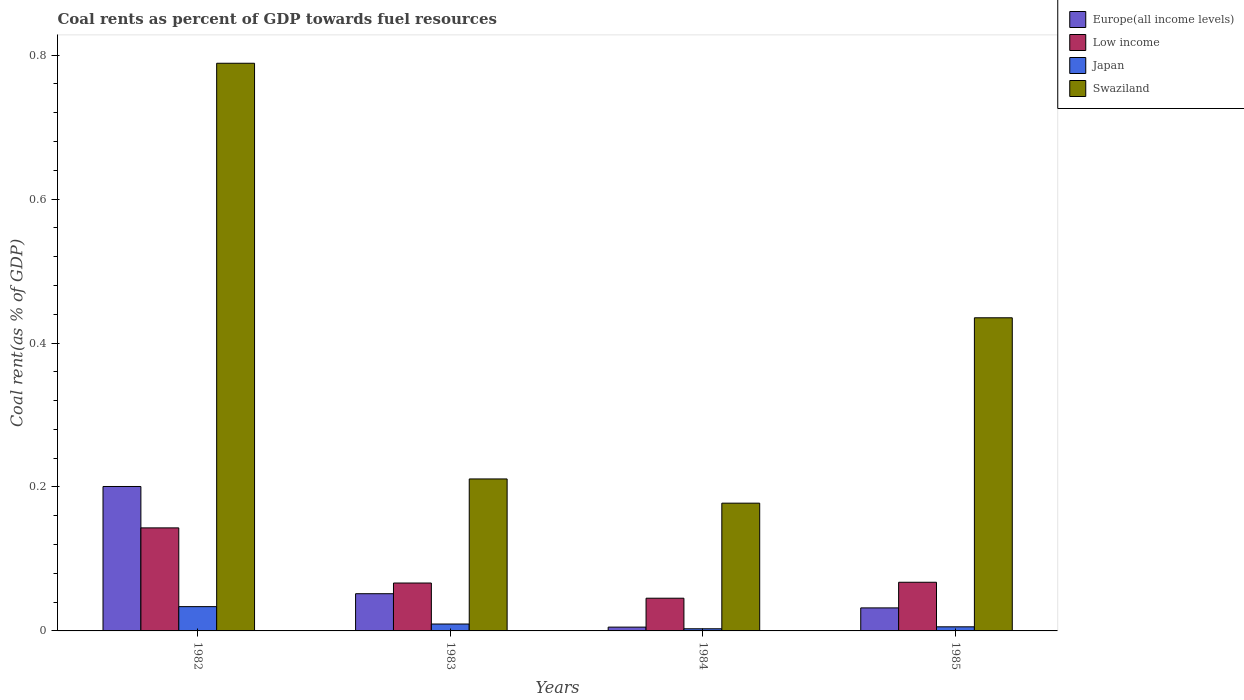How many different coloured bars are there?
Ensure brevity in your answer.  4. How many groups of bars are there?
Provide a short and direct response. 4. Are the number of bars per tick equal to the number of legend labels?
Your response must be concise. Yes. Are the number of bars on each tick of the X-axis equal?
Offer a terse response. Yes. What is the coal rent in Japan in 1985?
Your response must be concise. 0.01. Across all years, what is the maximum coal rent in Japan?
Make the answer very short. 0.03. Across all years, what is the minimum coal rent in Europe(all income levels)?
Ensure brevity in your answer.  0.01. In which year was the coal rent in Low income minimum?
Provide a short and direct response. 1984. What is the total coal rent in Europe(all income levels) in the graph?
Offer a terse response. 0.29. What is the difference between the coal rent in Japan in 1984 and that in 1985?
Provide a short and direct response. -0. What is the difference between the coal rent in Europe(all income levels) in 1982 and the coal rent in Swaziland in 1983?
Provide a short and direct response. -0.01. What is the average coal rent in Swaziland per year?
Offer a very short reply. 0.4. In the year 1982, what is the difference between the coal rent in Low income and coal rent in Swaziland?
Provide a succinct answer. -0.65. What is the ratio of the coal rent in Europe(all income levels) in 1982 to that in 1983?
Offer a terse response. 3.88. Is the coal rent in Low income in 1982 less than that in 1984?
Your answer should be very brief. No. What is the difference between the highest and the second highest coal rent in Swaziland?
Provide a short and direct response. 0.35. What is the difference between the highest and the lowest coal rent in Swaziland?
Provide a short and direct response. 0.61. What does the 1st bar from the left in 1985 represents?
Offer a terse response. Europe(all income levels). What does the 3rd bar from the right in 1984 represents?
Offer a very short reply. Low income. Is it the case that in every year, the sum of the coal rent in Japan and coal rent in Low income is greater than the coal rent in Europe(all income levels)?
Your response must be concise. No. What is the difference between two consecutive major ticks on the Y-axis?
Offer a terse response. 0.2. Does the graph contain any zero values?
Provide a short and direct response. No. Does the graph contain grids?
Give a very brief answer. No. Where does the legend appear in the graph?
Offer a terse response. Top right. How many legend labels are there?
Provide a succinct answer. 4. How are the legend labels stacked?
Make the answer very short. Vertical. What is the title of the graph?
Your answer should be compact. Coal rents as percent of GDP towards fuel resources. What is the label or title of the Y-axis?
Keep it short and to the point. Coal rent(as % of GDP). What is the Coal rent(as % of GDP) in Europe(all income levels) in 1982?
Your answer should be compact. 0.2. What is the Coal rent(as % of GDP) of Low income in 1982?
Provide a succinct answer. 0.14. What is the Coal rent(as % of GDP) in Japan in 1982?
Your answer should be compact. 0.03. What is the Coal rent(as % of GDP) of Swaziland in 1982?
Your answer should be very brief. 0.79. What is the Coal rent(as % of GDP) in Europe(all income levels) in 1983?
Provide a succinct answer. 0.05. What is the Coal rent(as % of GDP) in Low income in 1983?
Provide a short and direct response. 0.07. What is the Coal rent(as % of GDP) of Japan in 1983?
Offer a very short reply. 0.01. What is the Coal rent(as % of GDP) of Swaziland in 1983?
Give a very brief answer. 0.21. What is the Coal rent(as % of GDP) of Europe(all income levels) in 1984?
Offer a very short reply. 0.01. What is the Coal rent(as % of GDP) of Low income in 1984?
Provide a succinct answer. 0.05. What is the Coal rent(as % of GDP) of Japan in 1984?
Your answer should be compact. 0. What is the Coal rent(as % of GDP) of Swaziland in 1984?
Ensure brevity in your answer.  0.18. What is the Coal rent(as % of GDP) in Europe(all income levels) in 1985?
Give a very brief answer. 0.03. What is the Coal rent(as % of GDP) of Low income in 1985?
Provide a succinct answer. 0.07. What is the Coal rent(as % of GDP) in Japan in 1985?
Your answer should be very brief. 0.01. What is the Coal rent(as % of GDP) in Swaziland in 1985?
Ensure brevity in your answer.  0.44. Across all years, what is the maximum Coal rent(as % of GDP) of Europe(all income levels)?
Provide a succinct answer. 0.2. Across all years, what is the maximum Coal rent(as % of GDP) of Low income?
Your answer should be very brief. 0.14. Across all years, what is the maximum Coal rent(as % of GDP) in Japan?
Offer a very short reply. 0.03. Across all years, what is the maximum Coal rent(as % of GDP) of Swaziland?
Your response must be concise. 0.79. Across all years, what is the minimum Coal rent(as % of GDP) in Europe(all income levels)?
Provide a succinct answer. 0.01. Across all years, what is the minimum Coal rent(as % of GDP) in Low income?
Ensure brevity in your answer.  0.05. Across all years, what is the minimum Coal rent(as % of GDP) of Japan?
Your answer should be very brief. 0. Across all years, what is the minimum Coal rent(as % of GDP) of Swaziland?
Provide a succinct answer. 0.18. What is the total Coal rent(as % of GDP) in Europe(all income levels) in the graph?
Your answer should be compact. 0.29. What is the total Coal rent(as % of GDP) of Low income in the graph?
Offer a very short reply. 0.32. What is the total Coal rent(as % of GDP) of Japan in the graph?
Offer a very short reply. 0.05. What is the total Coal rent(as % of GDP) in Swaziland in the graph?
Your response must be concise. 1.61. What is the difference between the Coal rent(as % of GDP) in Europe(all income levels) in 1982 and that in 1983?
Your answer should be compact. 0.15. What is the difference between the Coal rent(as % of GDP) of Low income in 1982 and that in 1983?
Offer a terse response. 0.08. What is the difference between the Coal rent(as % of GDP) of Japan in 1982 and that in 1983?
Make the answer very short. 0.02. What is the difference between the Coal rent(as % of GDP) in Swaziland in 1982 and that in 1983?
Offer a terse response. 0.58. What is the difference between the Coal rent(as % of GDP) of Europe(all income levels) in 1982 and that in 1984?
Your answer should be very brief. 0.2. What is the difference between the Coal rent(as % of GDP) of Low income in 1982 and that in 1984?
Provide a succinct answer. 0.1. What is the difference between the Coal rent(as % of GDP) in Japan in 1982 and that in 1984?
Your answer should be very brief. 0.03. What is the difference between the Coal rent(as % of GDP) of Swaziland in 1982 and that in 1984?
Provide a short and direct response. 0.61. What is the difference between the Coal rent(as % of GDP) of Europe(all income levels) in 1982 and that in 1985?
Your answer should be very brief. 0.17. What is the difference between the Coal rent(as % of GDP) of Low income in 1982 and that in 1985?
Keep it short and to the point. 0.08. What is the difference between the Coal rent(as % of GDP) in Japan in 1982 and that in 1985?
Your answer should be compact. 0.03. What is the difference between the Coal rent(as % of GDP) of Swaziland in 1982 and that in 1985?
Ensure brevity in your answer.  0.35. What is the difference between the Coal rent(as % of GDP) in Europe(all income levels) in 1983 and that in 1984?
Provide a succinct answer. 0.05. What is the difference between the Coal rent(as % of GDP) of Low income in 1983 and that in 1984?
Provide a succinct answer. 0.02. What is the difference between the Coal rent(as % of GDP) of Japan in 1983 and that in 1984?
Give a very brief answer. 0.01. What is the difference between the Coal rent(as % of GDP) of Swaziland in 1983 and that in 1984?
Offer a very short reply. 0.03. What is the difference between the Coal rent(as % of GDP) of Europe(all income levels) in 1983 and that in 1985?
Offer a very short reply. 0.02. What is the difference between the Coal rent(as % of GDP) of Low income in 1983 and that in 1985?
Provide a short and direct response. -0. What is the difference between the Coal rent(as % of GDP) of Japan in 1983 and that in 1985?
Give a very brief answer. 0. What is the difference between the Coal rent(as % of GDP) of Swaziland in 1983 and that in 1985?
Your answer should be very brief. -0.22. What is the difference between the Coal rent(as % of GDP) of Europe(all income levels) in 1984 and that in 1985?
Offer a very short reply. -0.03. What is the difference between the Coal rent(as % of GDP) in Low income in 1984 and that in 1985?
Provide a succinct answer. -0.02. What is the difference between the Coal rent(as % of GDP) in Japan in 1984 and that in 1985?
Your response must be concise. -0. What is the difference between the Coal rent(as % of GDP) in Swaziland in 1984 and that in 1985?
Give a very brief answer. -0.26. What is the difference between the Coal rent(as % of GDP) in Europe(all income levels) in 1982 and the Coal rent(as % of GDP) in Low income in 1983?
Offer a terse response. 0.13. What is the difference between the Coal rent(as % of GDP) of Europe(all income levels) in 1982 and the Coal rent(as % of GDP) of Japan in 1983?
Ensure brevity in your answer.  0.19. What is the difference between the Coal rent(as % of GDP) in Europe(all income levels) in 1982 and the Coal rent(as % of GDP) in Swaziland in 1983?
Offer a very short reply. -0.01. What is the difference between the Coal rent(as % of GDP) of Low income in 1982 and the Coal rent(as % of GDP) of Japan in 1983?
Provide a short and direct response. 0.13. What is the difference between the Coal rent(as % of GDP) of Low income in 1982 and the Coal rent(as % of GDP) of Swaziland in 1983?
Provide a short and direct response. -0.07. What is the difference between the Coal rent(as % of GDP) in Japan in 1982 and the Coal rent(as % of GDP) in Swaziland in 1983?
Keep it short and to the point. -0.18. What is the difference between the Coal rent(as % of GDP) of Europe(all income levels) in 1982 and the Coal rent(as % of GDP) of Low income in 1984?
Ensure brevity in your answer.  0.16. What is the difference between the Coal rent(as % of GDP) of Europe(all income levels) in 1982 and the Coal rent(as % of GDP) of Japan in 1984?
Offer a very short reply. 0.2. What is the difference between the Coal rent(as % of GDP) in Europe(all income levels) in 1982 and the Coal rent(as % of GDP) in Swaziland in 1984?
Ensure brevity in your answer.  0.02. What is the difference between the Coal rent(as % of GDP) of Low income in 1982 and the Coal rent(as % of GDP) of Japan in 1984?
Your response must be concise. 0.14. What is the difference between the Coal rent(as % of GDP) in Low income in 1982 and the Coal rent(as % of GDP) in Swaziland in 1984?
Your answer should be compact. -0.03. What is the difference between the Coal rent(as % of GDP) of Japan in 1982 and the Coal rent(as % of GDP) of Swaziland in 1984?
Ensure brevity in your answer.  -0.14. What is the difference between the Coal rent(as % of GDP) of Europe(all income levels) in 1982 and the Coal rent(as % of GDP) of Low income in 1985?
Keep it short and to the point. 0.13. What is the difference between the Coal rent(as % of GDP) of Europe(all income levels) in 1982 and the Coal rent(as % of GDP) of Japan in 1985?
Provide a short and direct response. 0.2. What is the difference between the Coal rent(as % of GDP) in Europe(all income levels) in 1982 and the Coal rent(as % of GDP) in Swaziland in 1985?
Your answer should be compact. -0.23. What is the difference between the Coal rent(as % of GDP) in Low income in 1982 and the Coal rent(as % of GDP) in Japan in 1985?
Your response must be concise. 0.14. What is the difference between the Coal rent(as % of GDP) of Low income in 1982 and the Coal rent(as % of GDP) of Swaziland in 1985?
Offer a very short reply. -0.29. What is the difference between the Coal rent(as % of GDP) of Japan in 1982 and the Coal rent(as % of GDP) of Swaziland in 1985?
Make the answer very short. -0.4. What is the difference between the Coal rent(as % of GDP) of Europe(all income levels) in 1983 and the Coal rent(as % of GDP) of Low income in 1984?
Offer a very short reply. 0.01. What is the difference between the Coal rent(as % of GDP) in Europe(all income levels) in 1983 and the Coal rent(as % of GDP) in Japan in 1984?
Your answer should be compact. 0.05. What is the difference between the Coal rent(as % of GDP) of Europe(all income levels) in 1983 and the Coal rent(as % of GDP) of Swaziland in 1984?
Offer a very short reply. -0.13. What is the difference between the Coal rent(as % of GDP) in Low income in 1983 and the Coal rent(as % of GDP) in Japan in 1984?
Your answer should be compact. 0.06. What is the difference between the Coal rent(as % of GDP) in Low income in 1983 and the Coal rent(as % of GDP) in Swaziland in 1984?
Your answer should be very brief. -0.11. What is the difference between the Coal rent(as % of GDP) in Japan in 1983 and the Coal rent(as % of GDP) in Swaziland in 1984?
Your answer should be compact. -0.17. What is the difference between the Coal rent(as % of GDP) in Europe(all income levels) in 1983 and the Coal rent(as % of GDP) in Low income in 1985?
Provide a short and direct response. -0.02. What is the difference between the Coal rent(as % of GDP) in Europe(all income levels) in 1983 and the Coal rent(as % of GDP) in Japan in 1985?
Provide a short and direct response. 0.05. What is the difference between the Coal rent(as % of GDP) of Europe(all income levels) in 1983 and the Coal rent(as % of GDP) of Swaziland in 1985?
Your answer should be compact. -0.38. What is the difference between the Coal rent(as % of GDP) in Low income in 1983 and the Coal rent(as % of GDP) in Japan in 1985?
Provide a short and direct response. 0.06. What is the difference between the Coal rent(as % of GDP) in Low income in 1983 and the Coal rent(as % of GDP) in Swaziland in 1985?
Provide a short and direct response. -0.37. What is the difference between the Coal rent(as % of GDP) in Japan in 1983 and the Coal rent(as % of GDP) in Swaziland in 1985?
Offer a very short reply. -0.43. What is the difference between the Coal rent(as % of GDP) in Europe(all income levels) in 1984 and the Coal rent(as % of GDP) in Low income in 1985?
Offer a very short reply. -0.06. What is the difference between the Coal rent(as % of GDP) in Europe(all income levels) in 1984 and the Coal rent(as % of GDP) in Japan in 1985?
Provide a short and direct response. -0. What is the difference between the Coal rent(as % of GDP) in Europe(all income levels) in 1984 and the Coal rent(as % of GDP) in Swaziland in 1985?
Provide a succinct answer. -0.43. What is the difference between the Coal rent(as % of GDP) of Low income in 1984 and the Coal rent(as % of GDP) of Japan in 1985?
Your response must be concise. 0.04. What is the difference between the Coal rent(as % of GDP) in Low income in 1984 and the Coal rent(as % of GDP) in Swaziland in 1985?
Your response must be concise. -0.39. What is the difference between the Coal rent(as % of GDP) in Japan in 1984 and the Coal rent(as % of GDP) in Swaziland in 1985?
Give a very brief answer. -0.43. What is the average Coal rent(as % of GDP) of Europe(all income levels) per year?
Offer a very short reply. 0.07. What is the average Coal rent(as % of GDP) of Low income per year?
Ensure brevity in your answer.  0.08. What is the average Coal rent(as % of GDP) in Japan per year?
Offer a terse response. 0.01. What is the average Coal rent(as % of GDP) of Swaziland per year?
Provide a succinct answer. 0.4. In the year 1982, what is the difference between the Coal rent(as % of GDP) of Europe(all income levels) and Coal rent(as % of GDP) of Low income?
Your answer should be compact. 0.06. In the year 1982, what is the difference between the Coal rent(as % of GDP) of Europe(all income levels) and Coal rent(as % of GDP) of Japan?
Provide a short and direct response. 0.17. In the year 1982, what is the difference between the Coal rent(as % of GDP) in Europe(all income levels) and Coal rent(as % of GDP) in Swaziland?
Keep it short and to the point. -0.59. In the year 1982, what is the difference between the Coal rent(as % of GDP) in Low income and Coal rent(as % of GDP) in Japan?
Ensure brevity in your answer.  0.11. In the year 1982, what is the difference between the Coal rent(as % of GDP) in Low income and Coal rent(as % of GDP) in Swaziland?
Make the answer very short. -0.65. In the year 1982, what is the difference between the Coal rent(as % of GDP) in Japan and Coal rent(as % of GDP) in Swaziland?
Your answer should be very brief. -0.75. In the year 1983, what is the difference between the Coal rent(as % of GDP) in Europe(all income levels) and Coal rent(as % of GDP) in Low income?
Keep it short and to the point. -0.01. In the year 1983, what is the difference between the Coal rent(as % of GDP) of Europe(all income levels) and Coal rent(as % of GDP) of Japan?
Your answer should be very brief. 0.04. In the year 1983, what is the difference between the Coal rent(as % of GDP) in Europe(all income levels) and Coal rent(as % of GDP) in Swaziland?
Offer a very short reply. -0.16. In the year 1983, what is the difference between the Coal rent(as % of GDP) in Low income and Coal rent(as % of GDP) in Japan?
Give a very brief answer. 0.06. In the year 1983, what is the difference between the Coal rent(as % of GDP) of Low income and Coal rent(as % of GDP) of Swaziland?
Provide a short and direct response. -0.14. In the year 1983, what is the difference between the Coal rent(as % of GDP) of Japan and Coal rent(as % of GDP) of Swaziland?
Your answer should be very brief. -0.2. In the year 1984, what is the difference between the Coal rent(as % of GDP) of Europe(all income levels) and Coal rent(as % of GDP) of Low income?
Ensure brevity in your answer.  -0.04. In the year 1984, what is the difference between the Coal rent(as % of GDP) of Europe(all income levels) and Coal rent(as % of GDP) of Japan?
Offer a very short reply. 0. In the year 1984, what is the difference between the Coal rent(as % of GDP) of Europe(all income levels) and Coal rent(as % of GDP) of Swaziland?
Provide a succinct answer. -0.17. In the year 1984, what is the difference between the Coal rent(as % of GDP) in Low income and Coal rent(as % of GDP) in Japan?
Your response must be concise. 0.04. In the year 1984, what is the difference between the Coal rent(as % of GDP) in Low income and Coal rent(as % of GDP) in Swaziland?
Your response must be concise. -0.13. In the year 1984, what is the difference between the Coal rent(as % of GDP) of Japan and Coal rent(as % of GDP) of Swaziland?
Make the answer very short. -0.17. In the year 1985, what is the difference between the Coal rent(as % of GDP) of Europe(all income levels) and Coal rent(as % of GDP) of Low income?
Provide a succinct answer. -0.04. In the year 1985, what is the difference between the Coal rent(as % of GDP) of Europe(all income levels) and Coal rent(as % of GDP) of Japan?
Provide a short and direct response. 0.03. In the year 1985, what is the difference between the Coal rent(as % of GDP) in Europe(all income levels) and Coal rent(as % of GDP) in Swaziland?
Offer a terse response. -0.4. In the year 1985, what is the difference between the Coal rent(as % of GDP) of Low income and Coal rent(as % of GDP) of Japan?
Offer a terse response. 0.06. In the year 1985, what is the difference between the Coal rent(as % of GDP) in Low income and Coal rent(as % of GDP) in Swaziland?
Your answer should be compact. -0.37. In the year 1985, what is the difference between the Coal rent(as % of GDP) in Japan and Coal rent(as % of GDP) in Swaziland?
Make the answer very short. -0.43. What is the ratio of the Coal rent(as % of GDP) of Europe(all income levels) in 1982 to that in 1983?
Give a very brief answer. 3.88. What is the ratio of the Coal rent(as % of GDP) of Low income in 1982 to that in 1983?
Offer a terse response. 2.15. What is the ratio of the Coal rent(as % of GDP) in Japan in 1982 to that in 1983?
Give a very brief answer. 3.52. What is the ratio of the Coal rent(as % of GDP) of Swaziland in 1982 to that in 1983?
Give a very brief answer. 3.74. What is the ratio of the Coal rent(as % of GDP) in Europe(all income levels) in 1982 to that in 1984?
Provide a succinct answer. 37.9. What is the ratio of the Coal rent(as % of GDP) of Low income in 1982 to that in 1984?
Ensure brevity in your answer.  3.15. What is the ratio of the Coal rent(as % of GDP) of Japan in 1982 to that in 1984?
Your response must be concise. 11.27. What is the ratio of the Coal rent(as % of GDP) in Swaziland in 1982 to that in 1984?
Provide a short and direct response. 4.44. What is the ratio of the Coal rent(as % of GDP) in Europe(all income levels) in 1982 to that in 1985?
Offer a terse response. 6.27. What is the ratio of the Coal rent(as % of GDP) in Low income in 1982 to that in 1985?
Your answer should be compact. 2.12. What is the ratio of the Coal rent(as % of GDP) of Japan in 1982 to that in 1985?
Offer a very short reply. 5.92. What is the ratio of the Coal rent(as % of GDP) in Swaziland in 1982 to that in 1985?
Your answer should be compact. 1.81. What is the ratio of the Coal rent(as % of GDP) in Europe(all income levels) in 1983 to that in 1984?
Your response must be concise. 9.77. What is the ratio of the Coal rent(as % of GDP) in Low income in 1983 to that in 1984?
Your response must be concise. 1.46. What is the ratio of the Coal rent(as % of GDP) in Japan in 1983 to that in 1984?
Offer a very short reply. 3.2. What is the ratio of the Coal rent(as % of GDP) in Swaziland in 1983 to that in 1984?
Provide a succinct answer. 1.19. What is the ratio of the Coal rent(as % of GDP) of Europe(all income levels) in 1983 to that in 1985?
Make the answer very short. 1.62. What is the ratio of the Coal rent(as % of GDP) of Low income in 1983 to that in 1985?
Your answer should be compact. 0.98. What is the ratio of the Coal rent(as % of GDP) in Japan in 1983 to that in 1985?
Your answer should be very brief. 1.68. What is the ratio of the Coal rent(as % of GDP) in Swaziland in 1983 to that in 1985?
Ensure brevity in your answer.  0.49. What is the ratio of the Coal rent(as % of GDP) in Europe(all income levels) in 1984 to that in 1985?
Your answer should be compact. 0.17. What is the ratio of the Coal rent(as % of GDP) of Low income in 1984 to that in 1985?
Make the answer very short. 0.67. What is the ratio of the Coal rent(as % of GDP) in Japan in 1984 to that in 1985?
Offer a terse response. 0.53. What is the ratio of the Coal rent(as % of GDP) in Swaziland in 1984 to that in 1985?
Provide a succinct answer. 0.41. What is the difference between the highest and the second highest Coal rent(as % of GDP) in Europe(all income levels)?
Keep it short and to the point. 0.15. What is the difference between the highest and the second highest Coal rent(as % of GDP) in Low income?
Offer a terse response. 0.08. What is the difference between the highest and the second highest Coal rent(as % of GDP) in Japan?
Offer a terse response. 0.02. What is the difference between the highest and the second highest Coal rent(as % of GDP) of Swaziland?
Your answer should be compact. 0.35. What is the difference between the highest and the lowest Coal rent(as % of GDP) in Europe(all income levels)?
Make the answer very short. 0.2. What is the difference between the highest and the lowest Coal rent(as % of GDP) in Low income?
Provide a succinct answer. 0.1. What is the difference between the highest and the lowest Coal rent(as % of GDP) of Japan?
Provide a succinct answer. 0.03. What is the difference between the highest and the lowest Coal rent(as % of GDP) of Swaziland?
Keep it short and to the point. 0.61. 